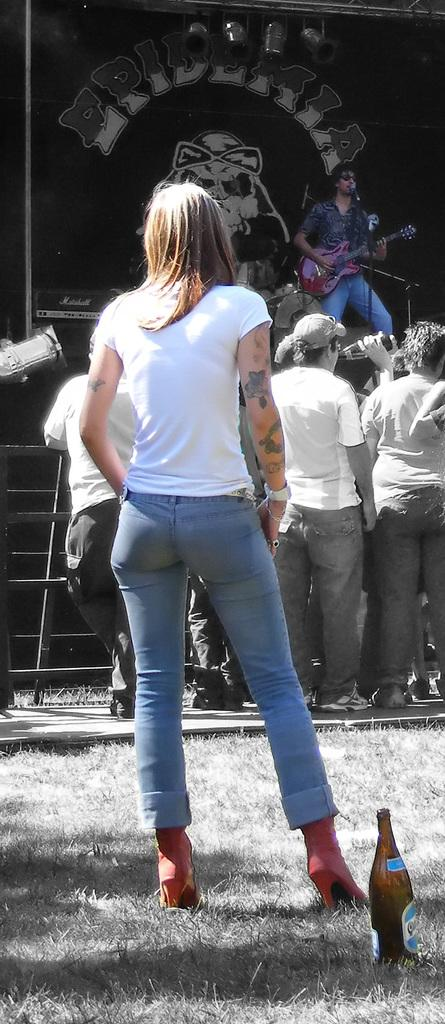Who is the main subject in the image? There is a woman in the image. What is the woman doing in the image? The woman is standing behind a wine bottle. What can be seen in the background of the image? There is a person playing guitar on a stage in the background, and people are watching them. What type of pest is visible on the guitar in the image? There is no pest visible on the guitar in the image. The image only shows a woman standing behind a wine bottle and a person playing guitar on a stage in the background, with people watching. 